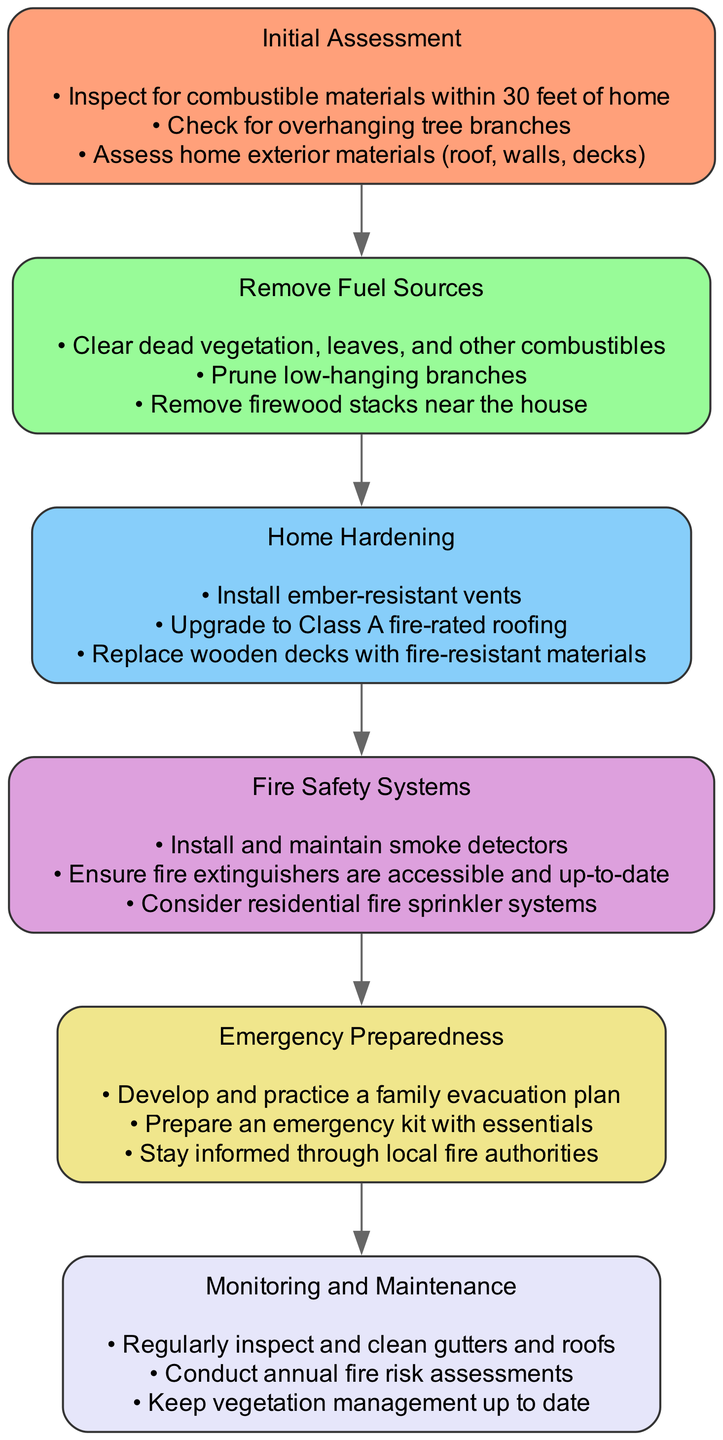what is the first step in the pathway? The first step is titled "Initial Assessment". You can find this at the top of the diagram, which indicates the starting point of the pathway.
Answer: Initial Assessment how many actions are listed under "Home Hardening"? The actions under "Home Hardening" include three specific tasks: "Install ember-resistant vents", "Upgrade to Class A fire-rated roofing", and "Replace wooden decks with fire-resistant materials". Counting these actions gives a total of three.
Answer: 3 which step immediately follows "Remove Fuel Sources"? The step that comes immediately after "Remove Fuel Sources" is "Home Hardening". You can see the directed connection from "Remove Fuel Sources" to "Home Hardening" in the flow of the diagram.
Answer: Home Hardening what is the last step in the pathway? The last step is titled "Monitoring and Maintenance". It appears as the final step in the sequence of the diagram.
Answer: Monitoring and Maintenance how many total steps are there in this diagram? The diagram contains a total of six steps that outline the fire hazard identification and mitigation process, listed sequentially from first to last.
Answer: 6 which action is associated with "Emergency Preparedness"? One action listed under "Emergency Preparedness" is "Develop and practice a family evacuation plan". This action denotes a critical preparedness step outlined in the diagram.
Answer: Develop and practice a family evacuation plan is there a step that includes installing smoke detectors? Yes, the step that includes installing smoke detectors is "Fire Safety Systems". This action is one of the key components identified for fire safety in the home.
Answer: Fire Safety Systems what type of materials should be used for roofing in "Home Hardening"? The recommended roofing material in "Home Hardening" is "Class A fire-rated roofing". This specifies the standard for fire resistance in roofing materials as per the diagram.
Answer: Class A fire-rated roofing which step involves clearing dead vegetation? The action of clearing dead vegetation is part of the "Remove Fuel Sources" step. This indicates the need to remove potential fire fuels around the home.
Answer: Remove Fuel Sources 